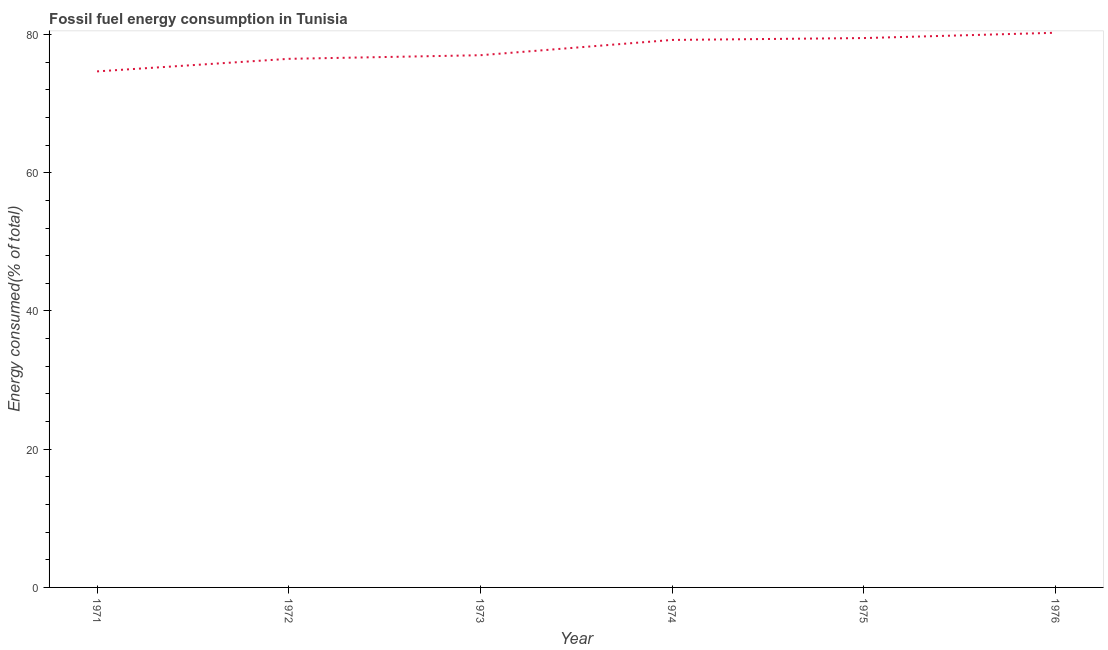What is the fossil fuel energy consumption in 1973?
Your answer should be very brief. 77. Across all years, what is the maximum fossil fuel energy consumption?
Your response must be concise. 80.25. Across all years, what is the minimum fossil fuel energy consumption?
Offer a terse response. 74.66. In which year was the fossil fuel energy consumption maximum?
Offer a very short reply. 1976. What is the sum of the fossil fuel energy consumption?
Provide a succinct answer. 467.11. What is the difference between the fossil fuel energy consumption in 1971 and 1976?
Provide a succinct answer. -5.59. What is the average fossil fuel energy consumption per year?
Offer a terse response. 77.85. What is the median fossil fuel energy consumption?
Provide a succinct answer. 78.11. What is the ratio of the fossil fuel energy consumption in 1975 to that in 1976?
Give a very brief answer. 0.99. What is the difference between the highest and the second highest fossil fuel energy consumption?
Your answer should be very brief. 0.77. Is the sum of the fossil fuel energy consumption in 1973 and 1974 greater than the maximum fossil fuel energy consumption across all years?
Your answer should be very brief. Yes. What is the difference between the highest and the lowest fossil fuel energy consumption?
Offer a very short reply. 5.59. In how many years, is the fossil fuel energy consumption greater than the average fossil fuel energy consumption taken over all years?
Offer a very short reply. 3. How many lines are there?
Offer a very short reply. 1. What is the difference between two consecutive major ticks on the Y-axis?
Give a very brief answer. 20. Does the graph contain any zero values?
Give a very brief answer. No. What is the title of the graph?
Make the answer very short. Fossil fuel energy consumption in Tunisia. What is the label or title of the Y-axis?
Your answer should be compact. Energy consumed(% of total). What is the Energy consumed(% of total) of 1971?
Give a very brief answer. 74.66. What is the Energy consumed(% of total) in 1972?
Ensure brevity in your answer.  76.48. What is the Energy consumed(% of total) of 1973?
Your response must be concise. 77. What is the Energy consumed(% of total) in 1974?
Give a very brief answer. 79.22. What is the Energy consumed(% of total) in 1975?
Make the answer very short. 79.49. What is the Energy consumed(% of total) of 1976?
Your answer should be compact. 80.25. What is the difference between the Energy consumed(% of total) in 1971 and 1972?
Offer a very short reply. -1.82. What is the difference between the Energy consumed(% of total) in 1971 and 1973?
Offer a terse response. -2.34. What is the difference between the Energy consumed(% of total) in 1971 and 1974?
Offer a very short reply. -4.55. What is the difference between the Energy consumed(% of total) in 1971 and 1975?
Provide a short and direct response. -4.82. What is the difference between the Energy consumed(% of total) in 1971 and 1976?
Provide a succinct answer. -5.59. What is the difference between the Energy consumed(% of total) in 1972 and 1973?
Your answer should be very brief. -0.52. What is the difference between the Energy consumed(% of total) in 1972 and 1974?
Provide a short and direct response. -2.73. What is the difference between the Energy consumed(% of total) in 1972 and 1975?
Provide a short and direct response. -3. What is the difference between the Energy consumed(% of total) in 1972 and 1976?
Your answer should be compact. -3.77. What is the difference between the Energy consumed(% of total) in 1973 and 1974?
Keep it short and to the point. -2.21. What is the difference between the Energy consumed(% of total) in 1973 and 1975?
Your answer should be compact. -2.48. What is the difference between the Energy consumed(% of total) in 1973 and 1976?
Make the answer very short. -3.25. What is the difference between the Energy consumed(% of total) in 1974 and 1975?
Ensure brevity in your answer.  -0.27. What is the difference between the Energy consumed(% of total) in 1974 and 1976?
Make the answer very short. -1.04. What is the difference between the Energy consumed(% of total) in 1975 and 1976?
Your answer should be compact. -0.77. What is the ratio of the Energy consumed(% of total) in 1971 to that in 1973?
Your answer should be very brief. 0.97. What is the ratio of the Energy consumed(% of total) in 1971 to that in 1974?
Keep it short and to the point. 0.94. What is the ratio of the Energy consumed(% of total) in 1971 to that in 1975?
Keep it short and to the point. 0.94. What is the ratio of the Energy consumed(% of total) in 1972 to that in 1974?
Offer a very short reply. 0.96. What is the ratio of the Energy consumed(% of total) in 1972 to that in 1975?
Provide a short and direct response. 0.96. What is the ratio of the Energy consumed(% of total) in 1972 to that in 1976?
Give a very brief answer. 0.95. What is the ratio of the Energy consumed(% of total) in 1973 to that in 1974?
Provide a short and direct response. 0.97. What is the ratio of the Energy consumed(% of total) in 1973 to that in 1975?
Offer a terse response. 0.97. What is the ratio of the Energy consumed(% of total) in 1973 to that in 1976?
Give a very brief answer. 0.96. What is the ratio of the Energy consumed(% of total) in 1974 to that in 1976?
Keep it short and to the point. 0.99. 